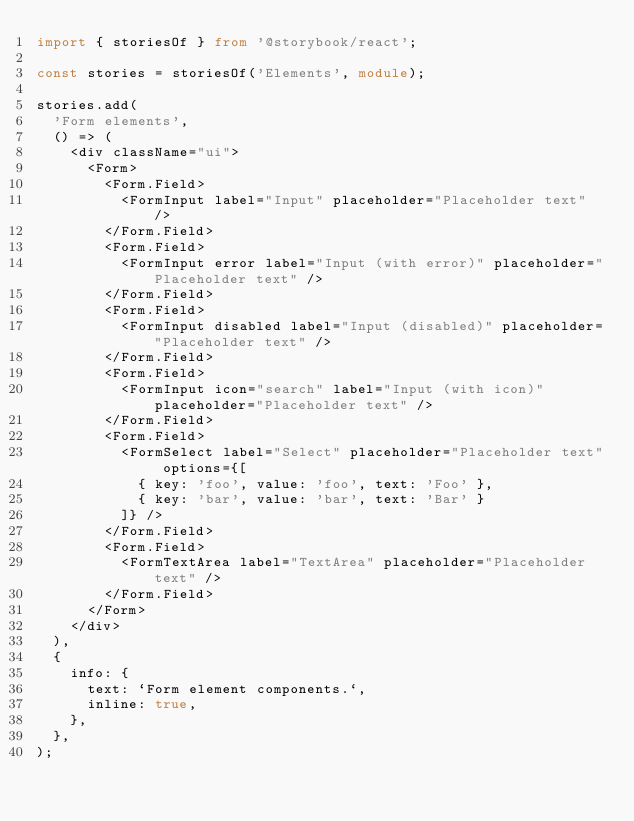<code> <loc_0><loc_0><loc_500><loc_500><_TypeScript_>import { storiesOf } from '@storybook/react';

const stories = storiesOf('Elements', module);

stories.add(
  'Form elements',
  () => (
    <div className="ui">
      <Form>
        <Form.Field>
          <FormInput label="Input" placeholder="Placeholder text" />
        </Form.Field>
        <Form.Field>
          <FormInput error label="Input (with error)" placeholder="Placeholder text" />
        </Form.Field>
        <Form.Field>
          <FormInput disabled label="Input (disabled)" placeholder="Placeholder text" />
        </Form.Field>
        <Form.Field>
          <FormInput icon="search" label="Input (with icon)" placeholder="Placeholder text" />
        </Form.Field>
        <Form.Field>
          <FormSelect label="Select" placeholder="Placeholder text" options={[
            { key: 'foo', value: 'foo', text: 'Foo' },
            { key: 'bar', value: 'bar', text: 'Bar' }
          ]} />
        </Form.Field>
        <Form.Field>
          <FormTextArea label="TextArea" placeholder="Placeholder text" />
        </Form.Field>
      </Form>
    </div>
  ),
  {
    info: {
      text: `Form element components.`,
      inline: true,
    },
  },
);
</code> 